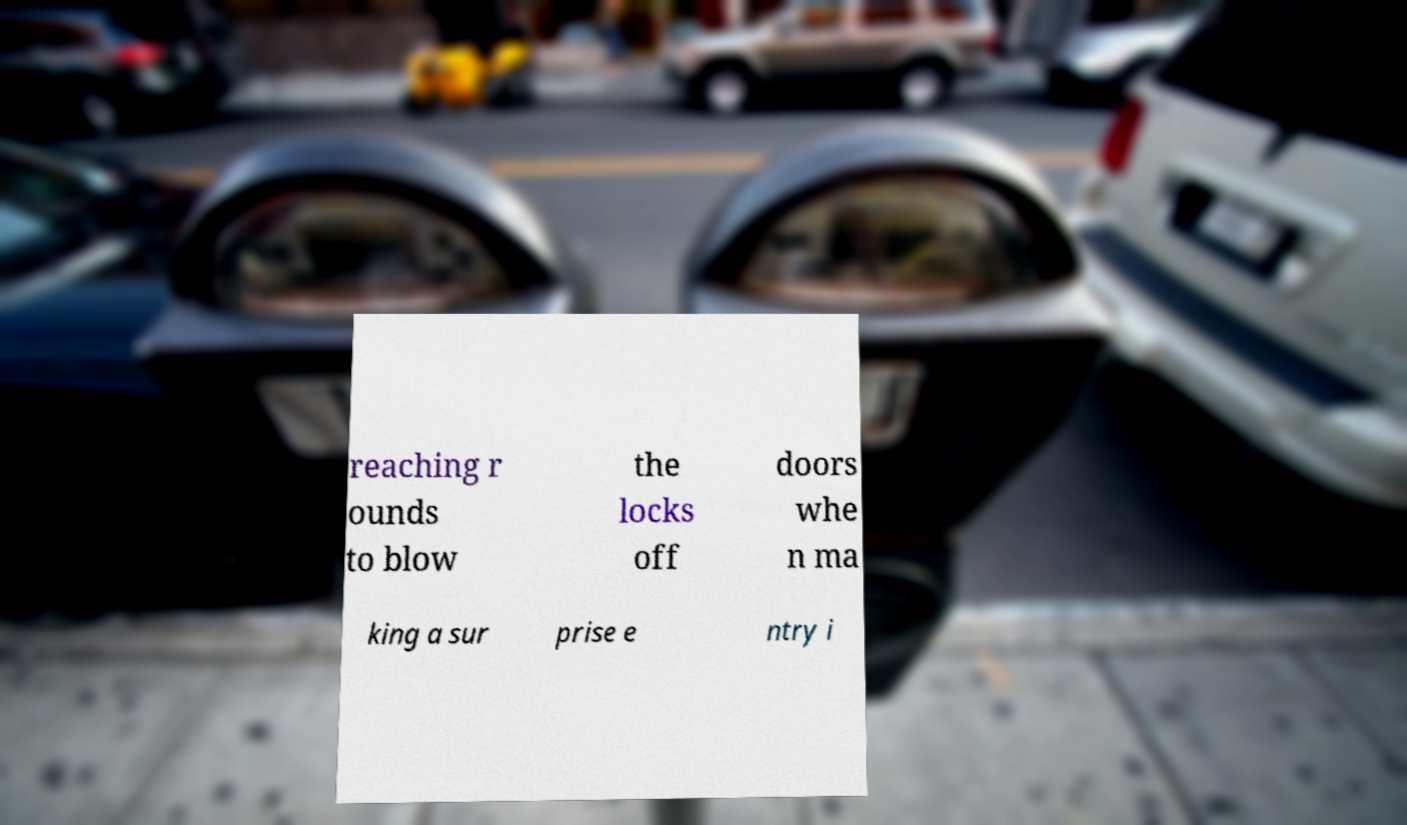What messages or text are displayed in this image? I need them in a readable, typed format. reaching r ounds to blow the locks off doors whe n ma king a sur prise e ntry i 